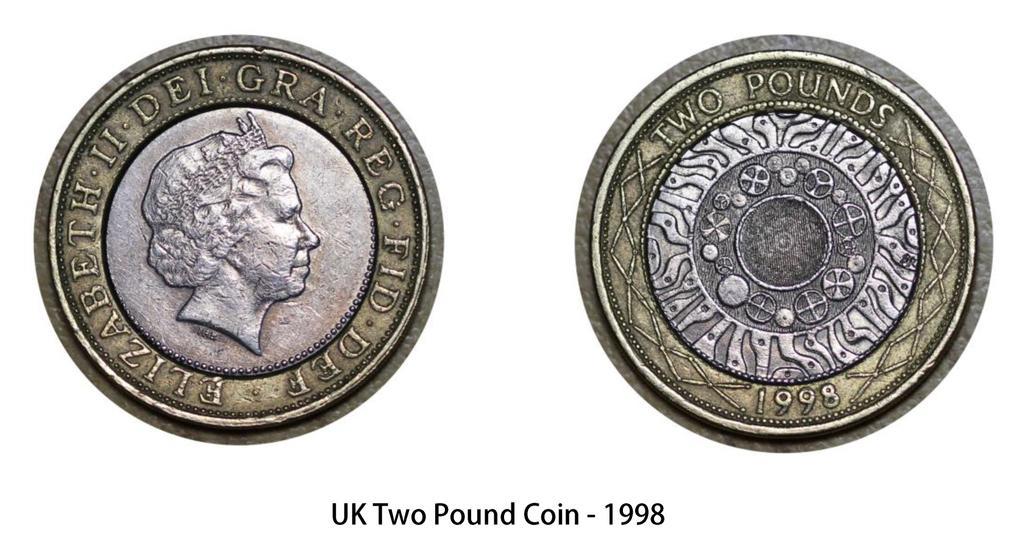How would you summarize this image in a sentence or two? In the image there is an image of a coin on its head and tails with some text below. 